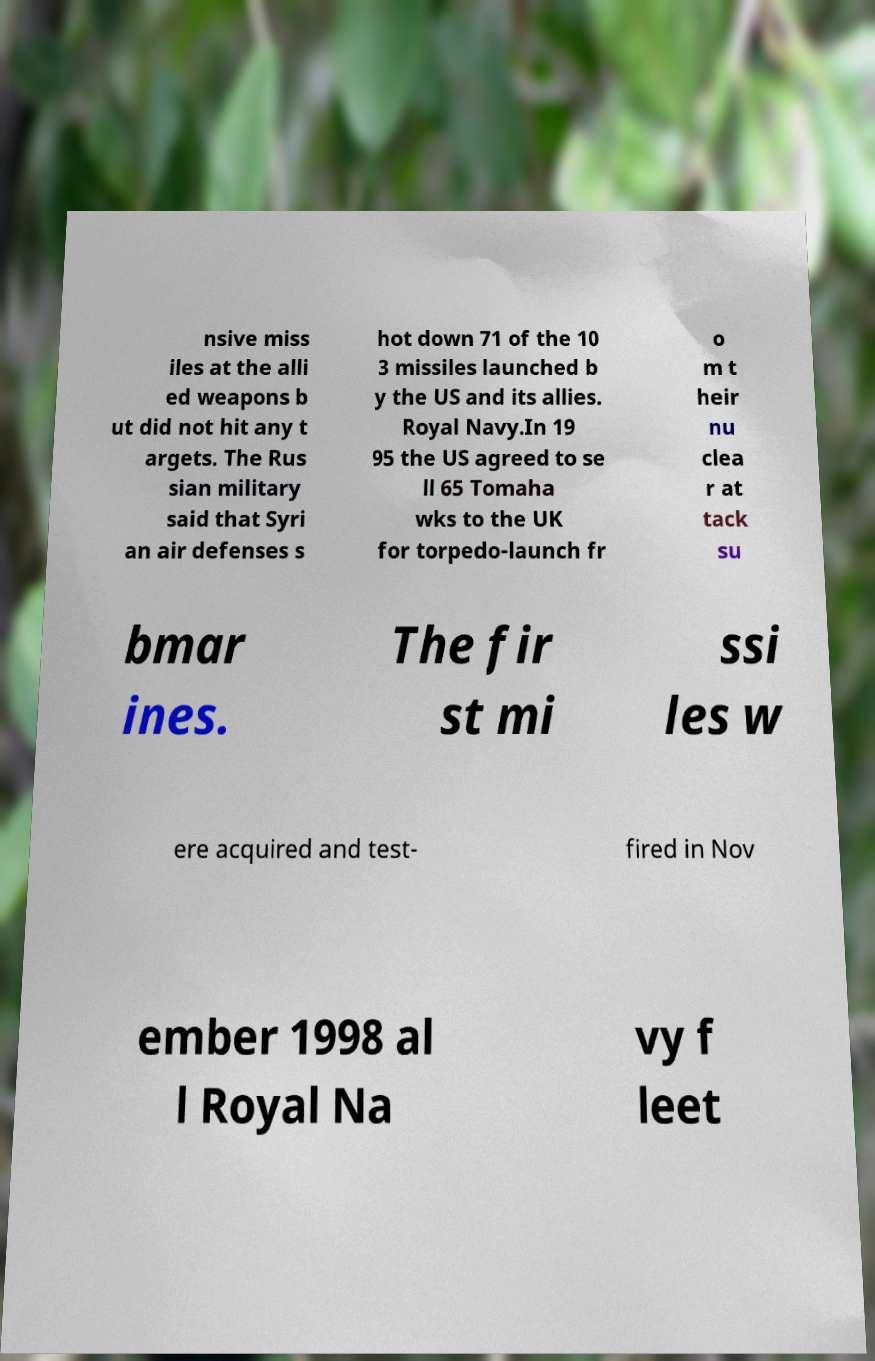Could you extract and type out the text from this image? nsive miss iles at the alli ed weapons b ut did not hit any t argets. The Rus sian military said that Syri an air defenses s hot down 71 of the 10 3 missiles launched b y the US and its allies. Royal Navy.In 19 95 the US agreed to se ll 65 Tomaha wks to the UK for torpedo-launch fr o m t heir nu clea r at tack su bmar ines. The fir st mi ssi les w ere acquired and test- fired in Nov ember 1998 al l Royal Na vy f leet 